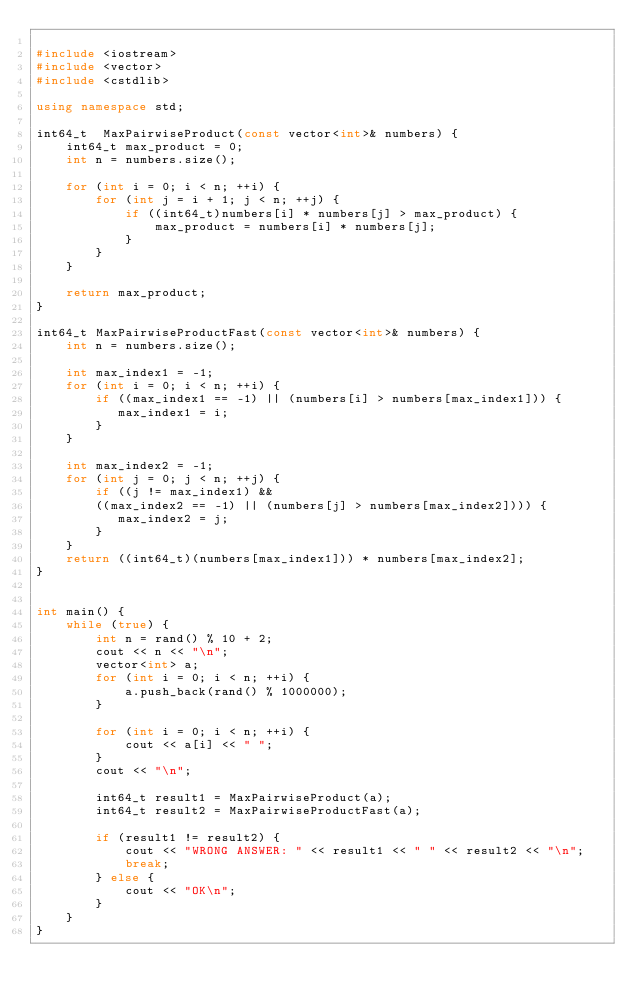Convert code to text. <code><loc_0><loc_0><loc_500><loc_500><_C++_>
#include <iostream>
#include <vector>
#include <cstdlib>

using namespace std;

int64_t  MaxPairwiseProduct(const vector<int>& numbers) {
    int64_t max_product = 0;
    int n = numbers.size();

    for (int i = 0; i < n; ++i) {
        for (int j = i + 1; j < n; ++j) {
            if ((int64_t)numbers[i] * numbers[j] > max_product) {
                max_product = numbers[i] * numbers[j];
            }
        }
    }

    return max_product;
}

int64_t MaxPairwiseProductFast(const vector<int>& numbers) {
    int n = numbers.size();

    int max_index1 = -1;
    for (int i = 0; i < n; ++i) {
        if ((max_index1 == -1) || (numbers[i] > numbers[max_index1])) {
           max_index1 = i;
        }
    }

    int max_index2 = -1;
    for (int j = 0; j < n; ++j) {
        if ((j != max_index1) &&
        ((max_index2 == -1) || (numbers[j] > numbers[max_index2]))) {
           max_index2 = j;
        }
    }
    return ((int64_t)(numbers[max_index1])) * numbers[max_index2];
}


int main() {
    while (true) {
        int n = rand() % 10 + 2;
        cout << n << "\n";
        vector<int> a;
        for (int i = 0; i < n; ++i) {
            a.push_back(rand() % 1000000);
        }

        for (int i = 0; i < n; ++i) {
            cout << a[i] << " ";
        }
        cout << "\n";

        int64_t result1 = MaxPairwiseProduct(a);
        int64_t result2 = MaxPairwiseProductFast(a);

        if (result1 != result2) {
            cout << "WRONG ANSWER: " << result1 << " " << result2 << "\n";
            break;
        } else {
            cout << "OK\n";
        }
    }
}
</code> 